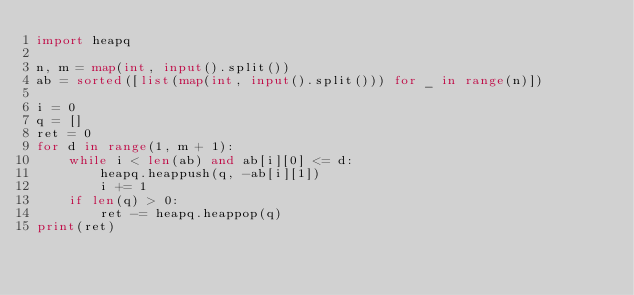Convert code to text. <code><loc_0><loc_0><loc_500><loc_500><_Python_>import heapq

n, m = map(int, input().split())
ab = sorted([list(map(int, input().split())) for _ in range(n)])

i = 0
q = []
ret = 0
for d in range(1, m + 1):
    while i < len(ab) and ab[i][0] <= d:
        heapq.heappush(q, -ab[i][1])
        i += 1
    if len(q) > 0:
        ret -= heapq.heappop(q)
print(ret)</code> 